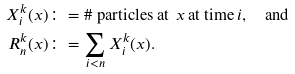<formula> <loc_0><loc_0><loc_500><loc_500>X ^ { k } _ { i } ( x ) \colon & = \# \text { particles at } \, x \, \text {at time} \, i , \quad \text {and} \\ R ^ { k } _ { n } ( x ) \colon & = \sum _ { i < n } X ^ { k } _ { i } ( x ) .</formula> 